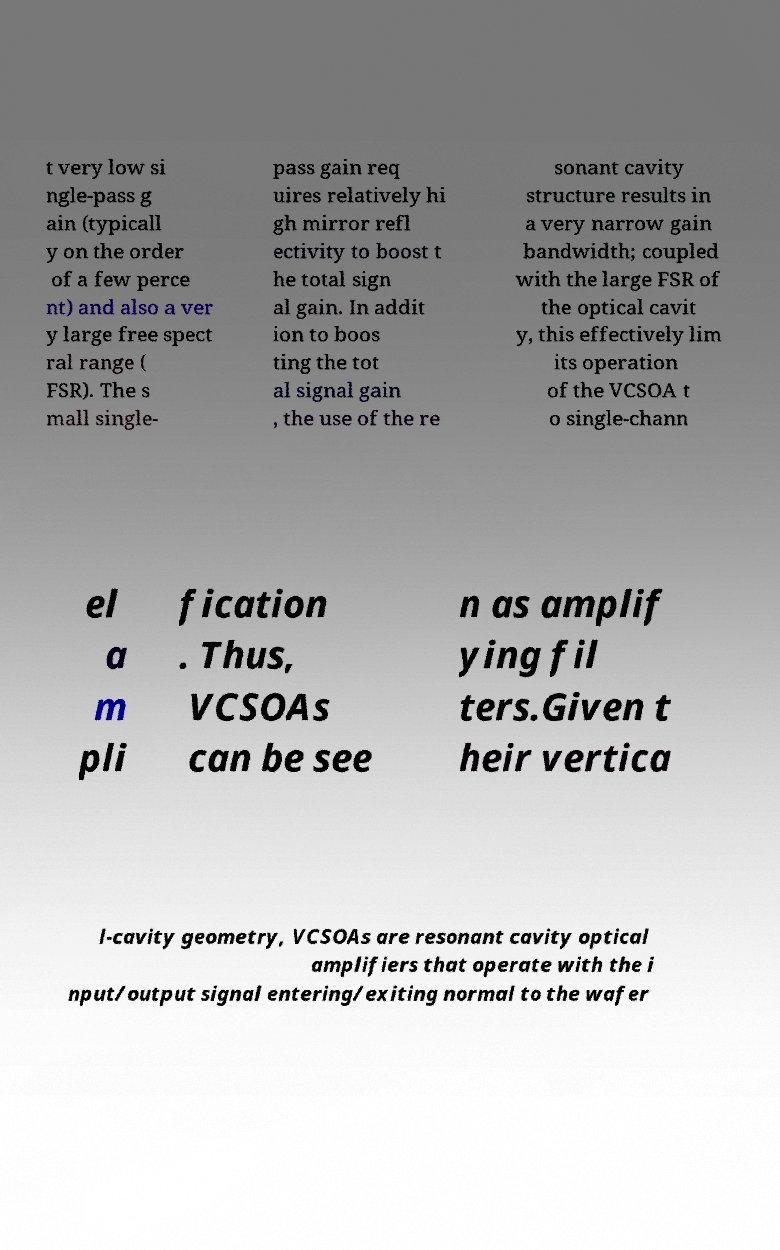There's text embedded in this image that I need extracted. Can you transcribe it verbatim? t very low si ngle-pass g ain (typicall y on the order of a few perce nt) and also a ver y large free spect ral range ( FSR). The s mall single- pass gain req uires relatively hi gh mirror refl ectivity to boost t he total sign al gain. In addit ion to boos ting the tot al signal gain , the use of the re sonant cavity structure results in a very narrow gain bandwidth; coupled with the large FSR of the optical cavit y, this effectively lim its operation of the VCSOA t o single-chann el a m pli fication . Thus, VCSOAs can be see n as amplif ying fil ters.Given t heir vertica l-cavity geometry, VCSOAs are resonant cavity optical amplifiers that operate with the i nput/output signal entering/exiting normal to the wafer 